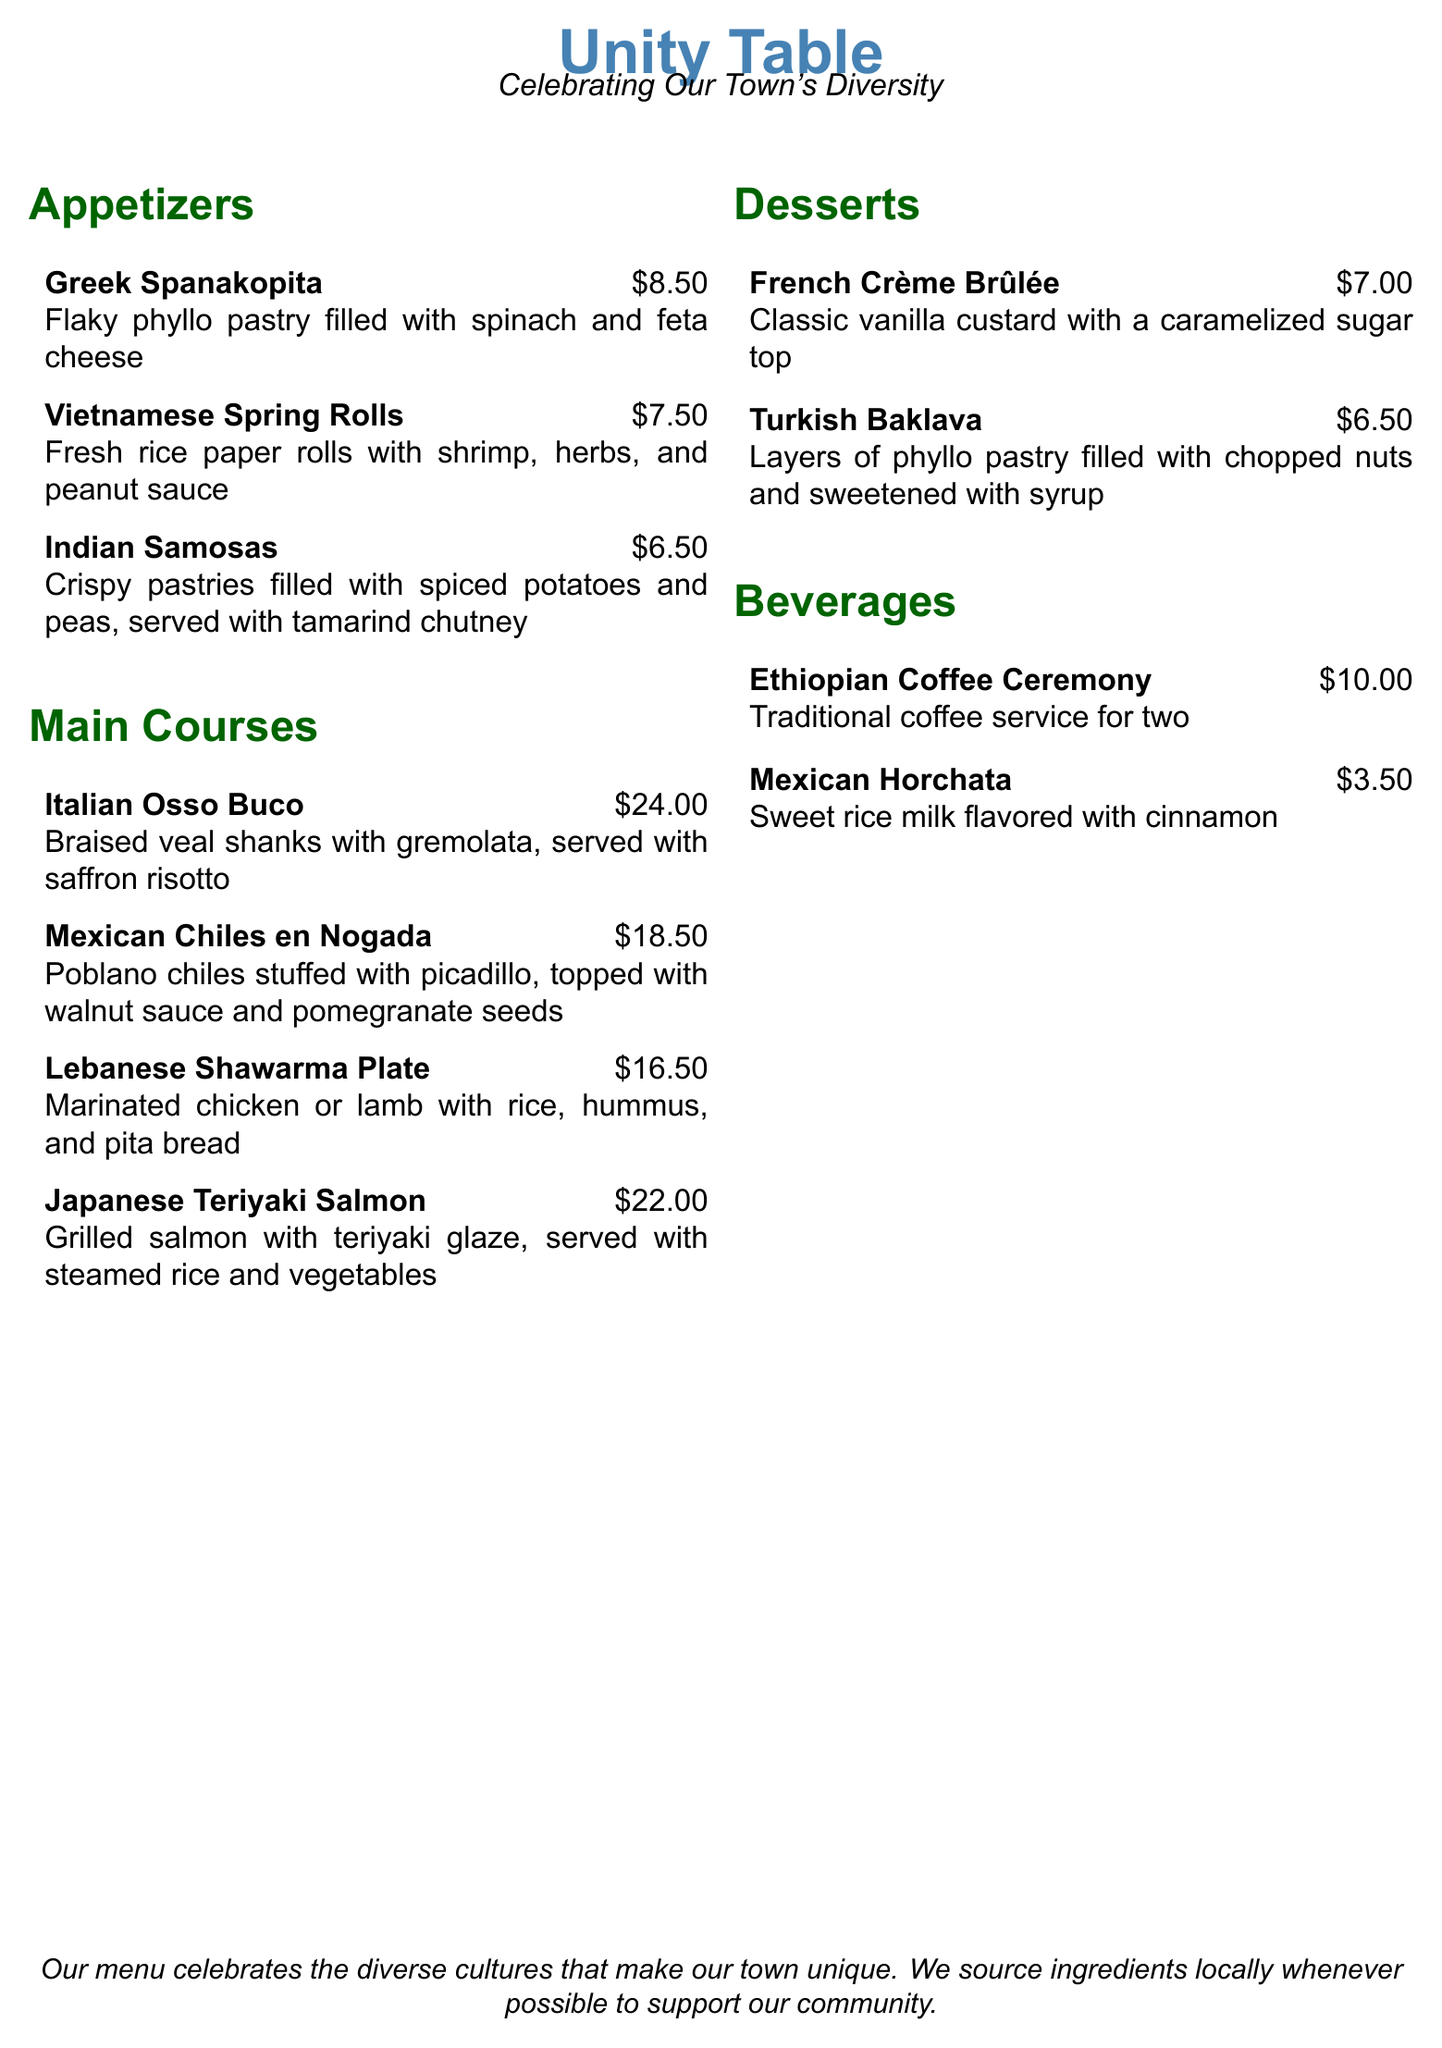What is the price of Greek Spanakopita? The price of the Greek Spanakopita is listed in the appetizers section of the menu.
Answer: $8.50 What type of fish is in the Japanese Teriyaki Salmon? The main ingredient of Japanese Teriyaki Salmon is mentioned in the main courses section of the menu.
Answer: Salmon Which dessert features caramelized sugar? The dessert that has a caramelized sugar top is mentioned in the desserts section.
Answer: Crème Brûlée How many appetizers are listed on the menu? The total number of appetizers is calculated by counting the items in the appetizers section.
Answer: 3 What cuisine is associated with Chiles en Nogada? The dish Chiles en Nogada is categorized under the main courses section, indicating its cultural origin.
Answer: Mexican Which beverage is traditional for coffee service? The beverage that is described as a traditional coffee service is found in the beverages section.
Answer: Ethiopian Coffee Ceremony What is the main ingredient in Indian Samosas? The filling of Indian Samosas is discussed in the appetizers section of the menu.
Answer: Spiced potatoes and peas What is the price of Turkish Baklava? The price of Turkish Baklava is specified in the desserts section of the menu.
Answer: $6.50 